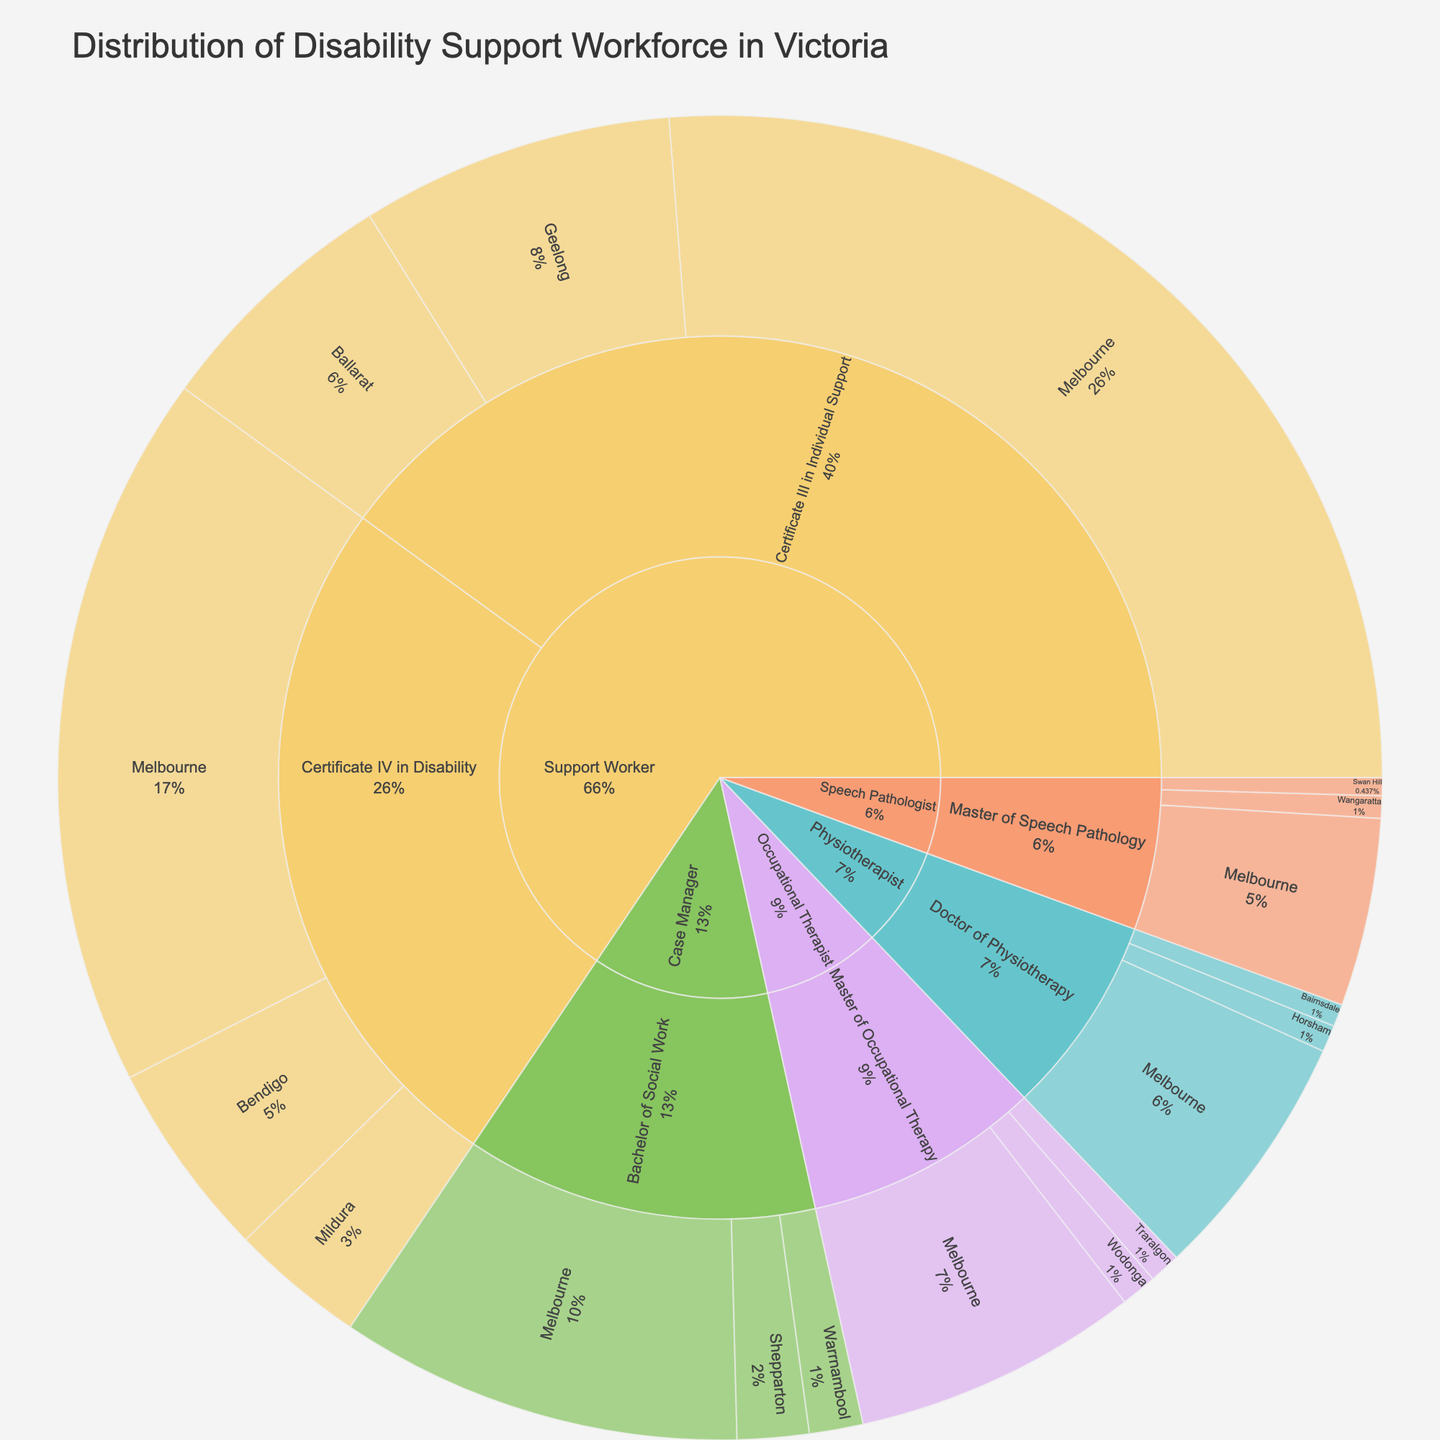What title is displayed on the sunburst plot? The title of a plot is usually displayed at the top and often describes the main subject or focus of the plot. In this case, we know it is about the distribution of the disability support workforce in Victoria.
Answer: Distribution of Disability Support Workforce in Victoria How many job roles are represented in the sunburst plot? In a sunburst plot with such data, job roles are an upper-level category. To identify them, look at the labels nearest the center of the plot.
Answer: 4 Which job role has the largest number of workers in Melbourne? To find this, locate the "Melbourne" portion of the plot and see which job role contributes the most workers. Since Melbourne is a key part of the "Location" layer, each segment can be analyzed by size or percentage displayed. The largest segment will be the answer.
Answer: Support Worker How many support workers in Victoria have a Certificate III in Individual Support? To determine this, sum the values for "Support Worker" segments associated with "Certificate III in Individual Support" across all locations. According to the data: Melbourne (1200), Geelong (350), and Ballarat (280). The total is 1200 + 350 + 280.
Answer: 1830 Which city has the greatest number of occupational therapists? Focus on the "Occupational Therapist" sections and compare the values for each city related to this job role. Identify which section is the largest.
Answer: Melbourne Compare the total number of case managers in Shepparton and Warrnambool. Which city has more case managers and by how many? Find the number of case managers in Shepparton and Warrnambool. Shepparton has 80, and Warrnambool has 60. Subtract the smaller number from the larger number to find the difference.
Answer: Shepparton, by 20 What is the proportion of Physiotherapists in Melbourne compared to Horsham and Bairnsdale combined? Physiotherapists in Melbourne are 280. Physiotherapists in Horsham and Bairnsdale combined is 30 + 25 = 55. The proportion is 280 / (280 + 55). Calculate the resulting ratio.
Answer: 280/335 ≈ 0.84 Which qualification appears most frequently in the plot? To find this, count the frequency each qualification appears next to the job role segments in the plot.
Answer: Certificate III in Individual Support How does the number of Speech Pathologists in Swan Hill compare to those in Wangaratta? Check and compare the values associated with "Speech Pathologist" in Swan Hill and Wangaratta. Swan Hill has 20 and Wangaratta has 25. Thus, Wangaratta has more Speech Pathologists.
Answer: Wangaratta, by 5 Which location has the smallest number of disability support workers overall? To determine this, add the numbers for each job role and qualification within each location. Identify the location with the smallest sum.
Answer: Swan Hill 